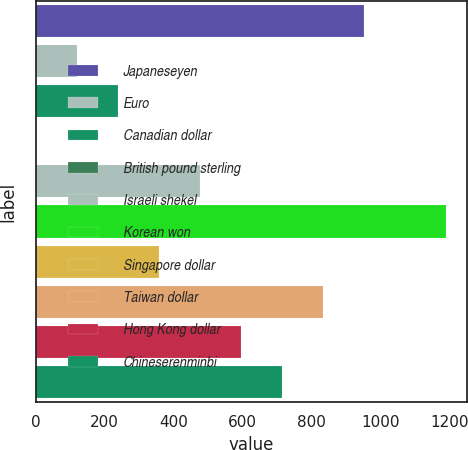Convert chart to OTSL. <chart><loc_0><loc_0><loc_500><loc_500><bar_chart><fcel>Japaneseyen<fcel>Euro<fcel>Canadian dollar<fcel>British pound sterling<fcel>Israeli shekel<fcel>Korean won<fcel>Singapore dollar<fcel>Taiwan dollar<fcel>Hong Kong dollar<fcel>Chineserenminbi<nl><fcel>952.11<fcel>119.53<fcel>238.47<fcel>0.59<fcel>476.35<fcel>1190<fcel>357.41<fcel>833.17<fcel>595.29<fcel>714.23<nl></chart> 